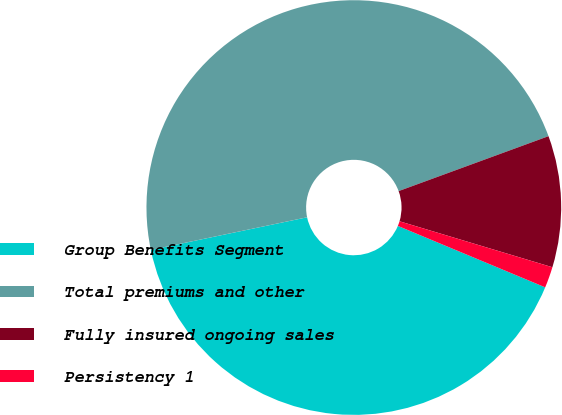<chart> <loc_0><loc_0><loc_500><loc_500><pie_chart><fcel>Group Benefits Segment<fcel>Total premiums and other<fcel>Fully insured ongoing sales<fcel>Persistency 1<nl><fcel>40.44%<fcel>47.69%<fcel>10.24%<fcel>1.64%<nl></chart> 